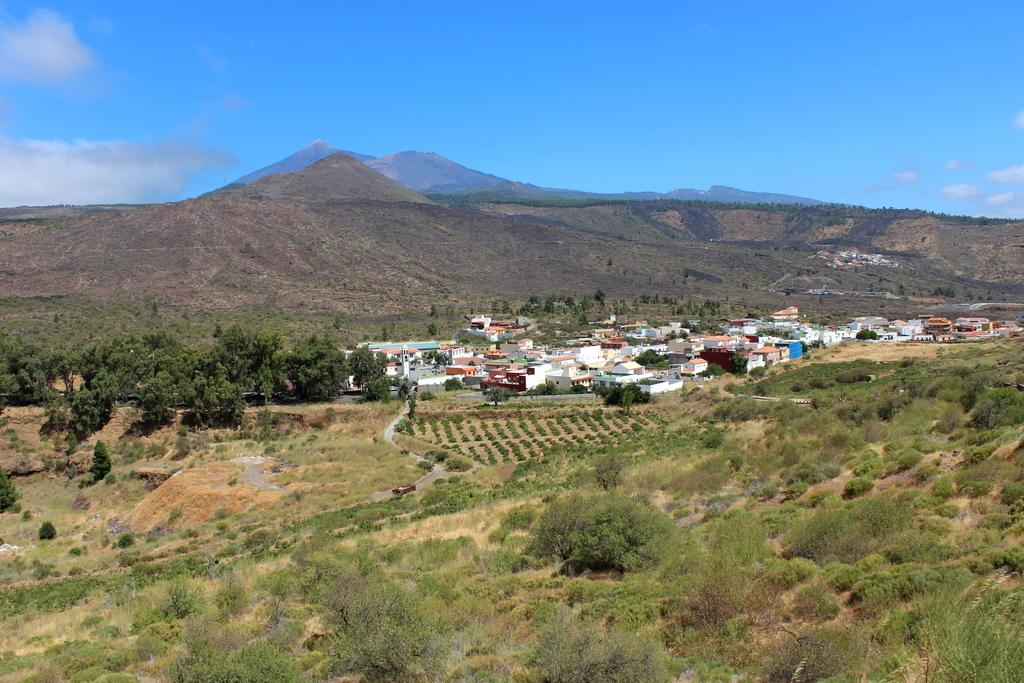What type of vegetation can be seen in the image? There are plants and trees in the image. What type of structures are visible in the image? There are houses in the image. What can be seen in the background of the image? There is a mountain and the sky in the background of the image. What is the condition of the sky in the image? Clouds are present in the sky in the image. How many loaves of bread can be seen in the image? There are no loaves of bread present in the image. What type of nation is depicted in the image? The image does not depict a nation; it features plants, trees, houses, a mountain, and the sky. 